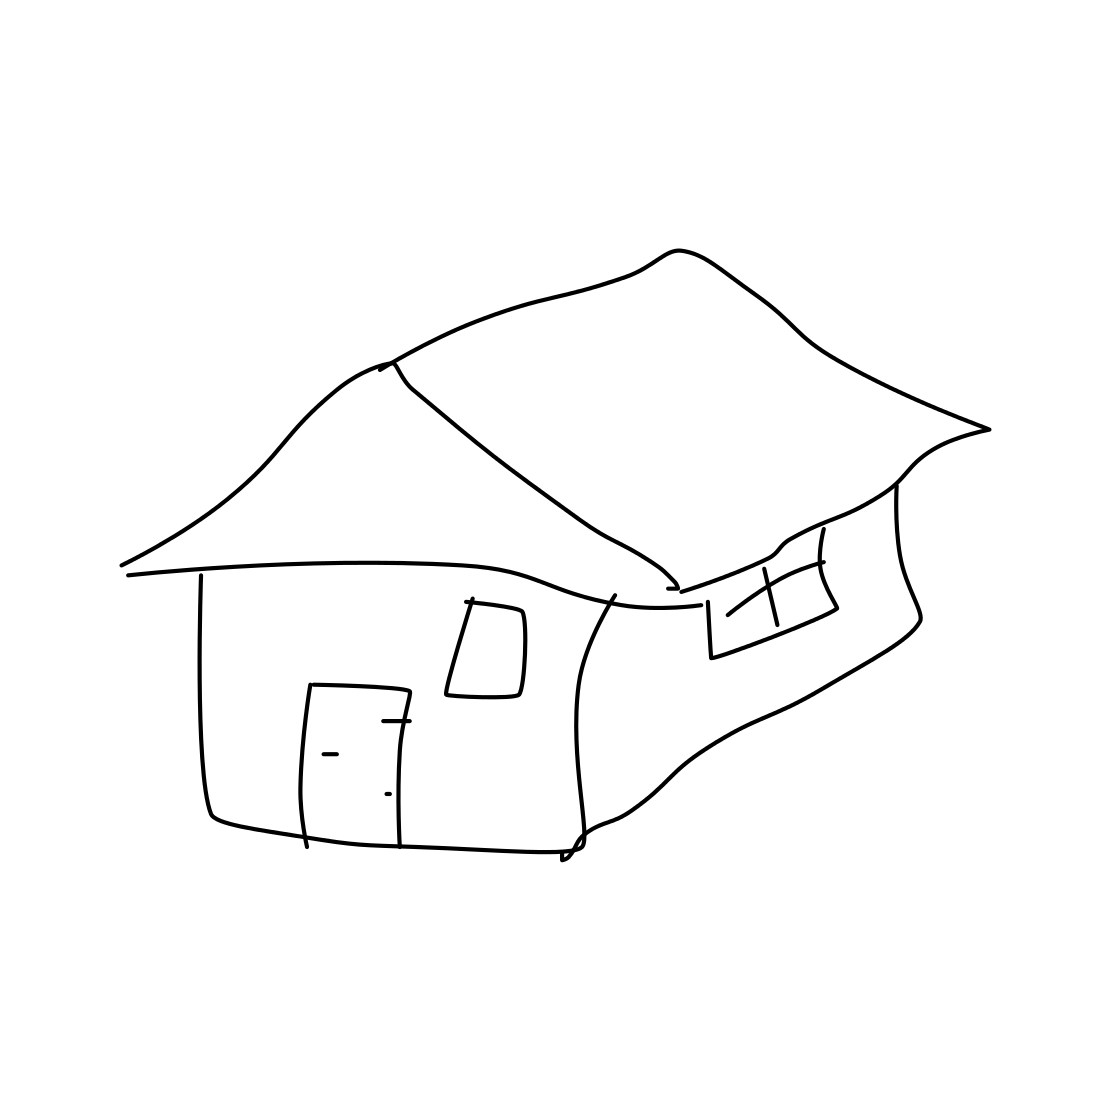What architectural style does the house seem to reflect? Given the simplicity of the drawing, it's challenging to definitively categorize the house's architectural style. However, the general shape could be loosely interpreted as resembling a basic gabled or pitched-roof structure, which is common in residential designs. 